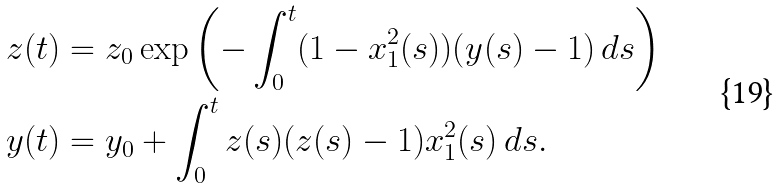<formula> <loc_0><loc_0><loc_500><loc_500>z ( t ) & = z _ { 0 } \exp \left ( - \int _ { 0 } ^ { t } ( 1 - x _ { 1 } ^ { 2 } ( s ) ) ( y ( s ) - 1 ) \, d s \right ) \\ y ( t ) & = y _ { 0 } + \int _ { 0 } ^ { t } z ( s ) ( z ( s ) - 1 ) x _ { 1 } ^ { 2 } ( s ) \, d s .</formula> 